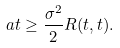Convert formula to latex. <formula><loc_0><loc_0><loc_500><loc_500>a t \geq \frac { \sigma ^ { 2 } } { 2 } R ( t , t ) .</formula> 